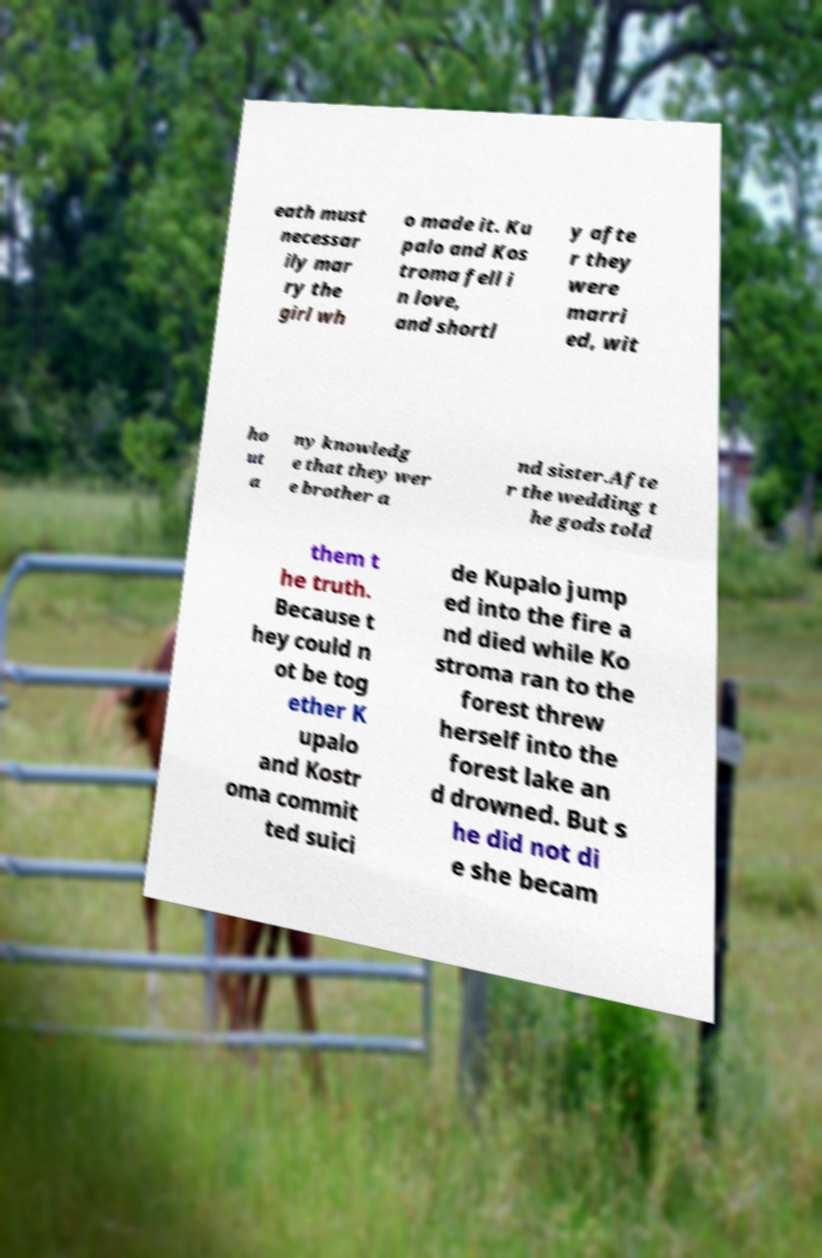What messages or text are displayed in this image? I need them in a readable, typed format. eath must necessar ily mar ry the girl wh o made it. Ku palo and Kos troma fell i n love, and shortl y afte r they were marri ed, wit ho ut a ny knowledg e that they wer e brother a nd sister.Afte r the wedding t he gods told them t he truth. Because t hey could n ot be tog ether K upalo and Kostr oma commit ted suici de Kupalo jump ed into the fire a nd died while Ko stroma ran to the forest threw herself into the forest lake an d drowned. But s he did not di e she becam 